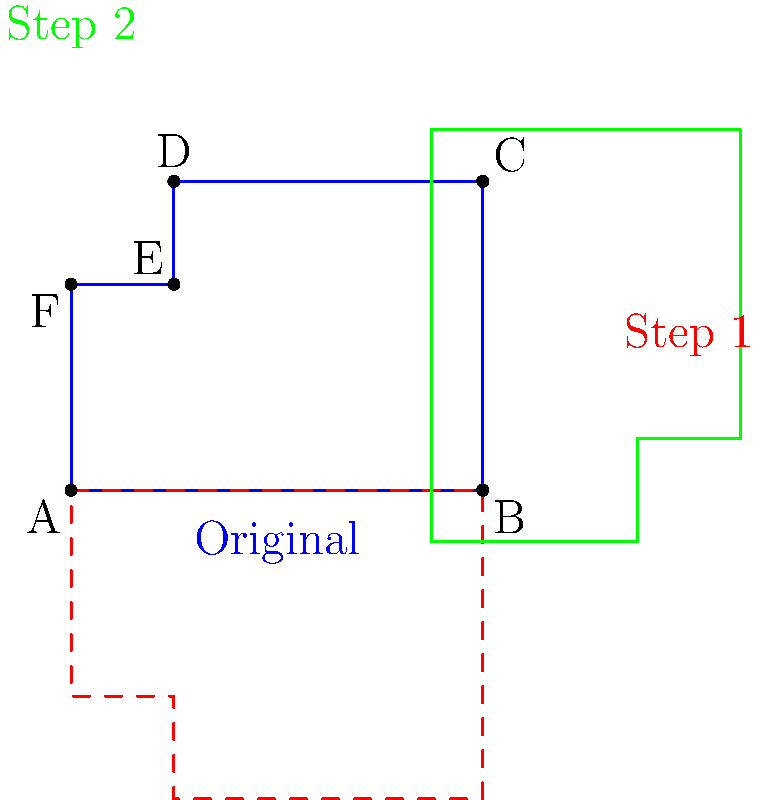In the popular Hindi TV drama "Yeh Rishta Kya Kehlata Hai," director Rajan Shahi often uses a clapperboard to signal the start of a scene. The shape in blue represents a simplified clapperboard. What sequence of transformations transforms the blue shape into the green shape? Let's approach this step-by-step:

1) First, observe the relationship between the blue (original) shape and the red (dashed) shape:
   - The red shape is a mirror image of the blue shape.
   - The line of reflection appears to be the bottom edge of the clapperboard (line AB).

2) Now, look at the relationship between the red shape and the green shape:
   - The green shape appears to be a 90-degree rotation of the red shape.
   - The center of rotation seems to be the midpoint of the entire figure.

3) To summarize the transformations:
   - Step 1: Reflection across line AB
   - Step 2: 90-degree clockwise rotation around the center point

4) In mathematical terms:
   - Let $R$ represent the reflection across line AB
   - Let $T$ represent the 90-degree clockwise rotation around the center point
   - The complete transformation can be written as $T \circ R$, where $\circ$ denotes composition of functions

Therefore, the sequence of transformations is: first a reflection across the bottom edge, followed by a 90-degree clockwise rotation around the center.
Answer: Reflection across bottom edge, then 90° clockwise rotation around center 